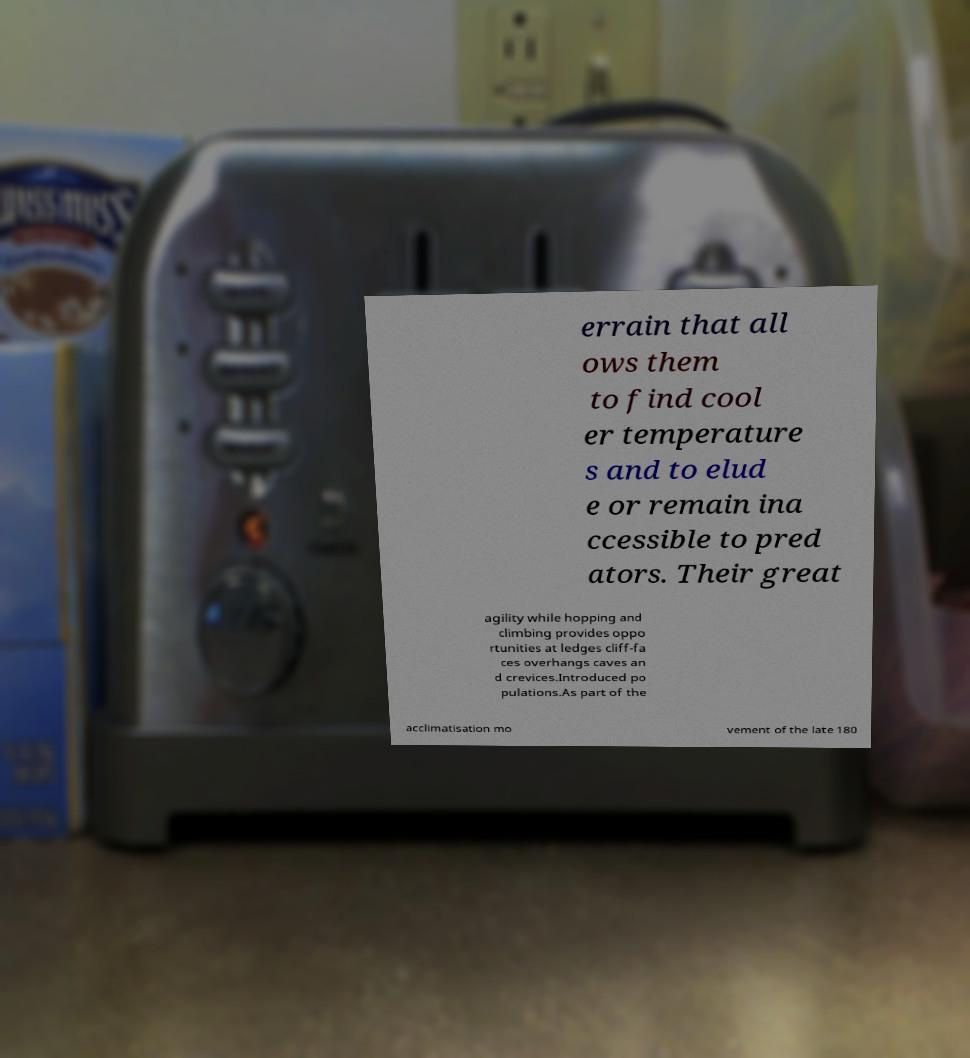For documentation purposes, I need the text within this image transcribed. Could you provide that? errain that all ows them to find cool er temperature s and to elud e or remain ina ccessible to pred ators. Their great agility while hopping and climbing provides oppo rtunities at ledges cliff-fa ces overhangs caves an d crevices.Introduced po pulations.As part of the acclimatisation mo vement of the late 180 